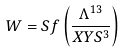Convert formula to latex. <formula><loc_0><loc_0><loc_500><loc_500>W = S f \left ( { \frac { \Lambda ^ { 1 3 } } { X Y S ^ { 3 } } } \right )</formula> 